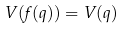Convert formula to latex. <formula><loc_0><loc_0><loc_500><loc_500>V ( f ( q ) ) = V ( q )</formula> 